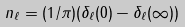<formula> <loc_0><loc_0><loc_500><loc_500>n _ { \ell } = ( 1 / \pi ) ( \delta _ { \ell } ( 0 ) - \delta _ { \ell } ( \infty ) )</formula> 